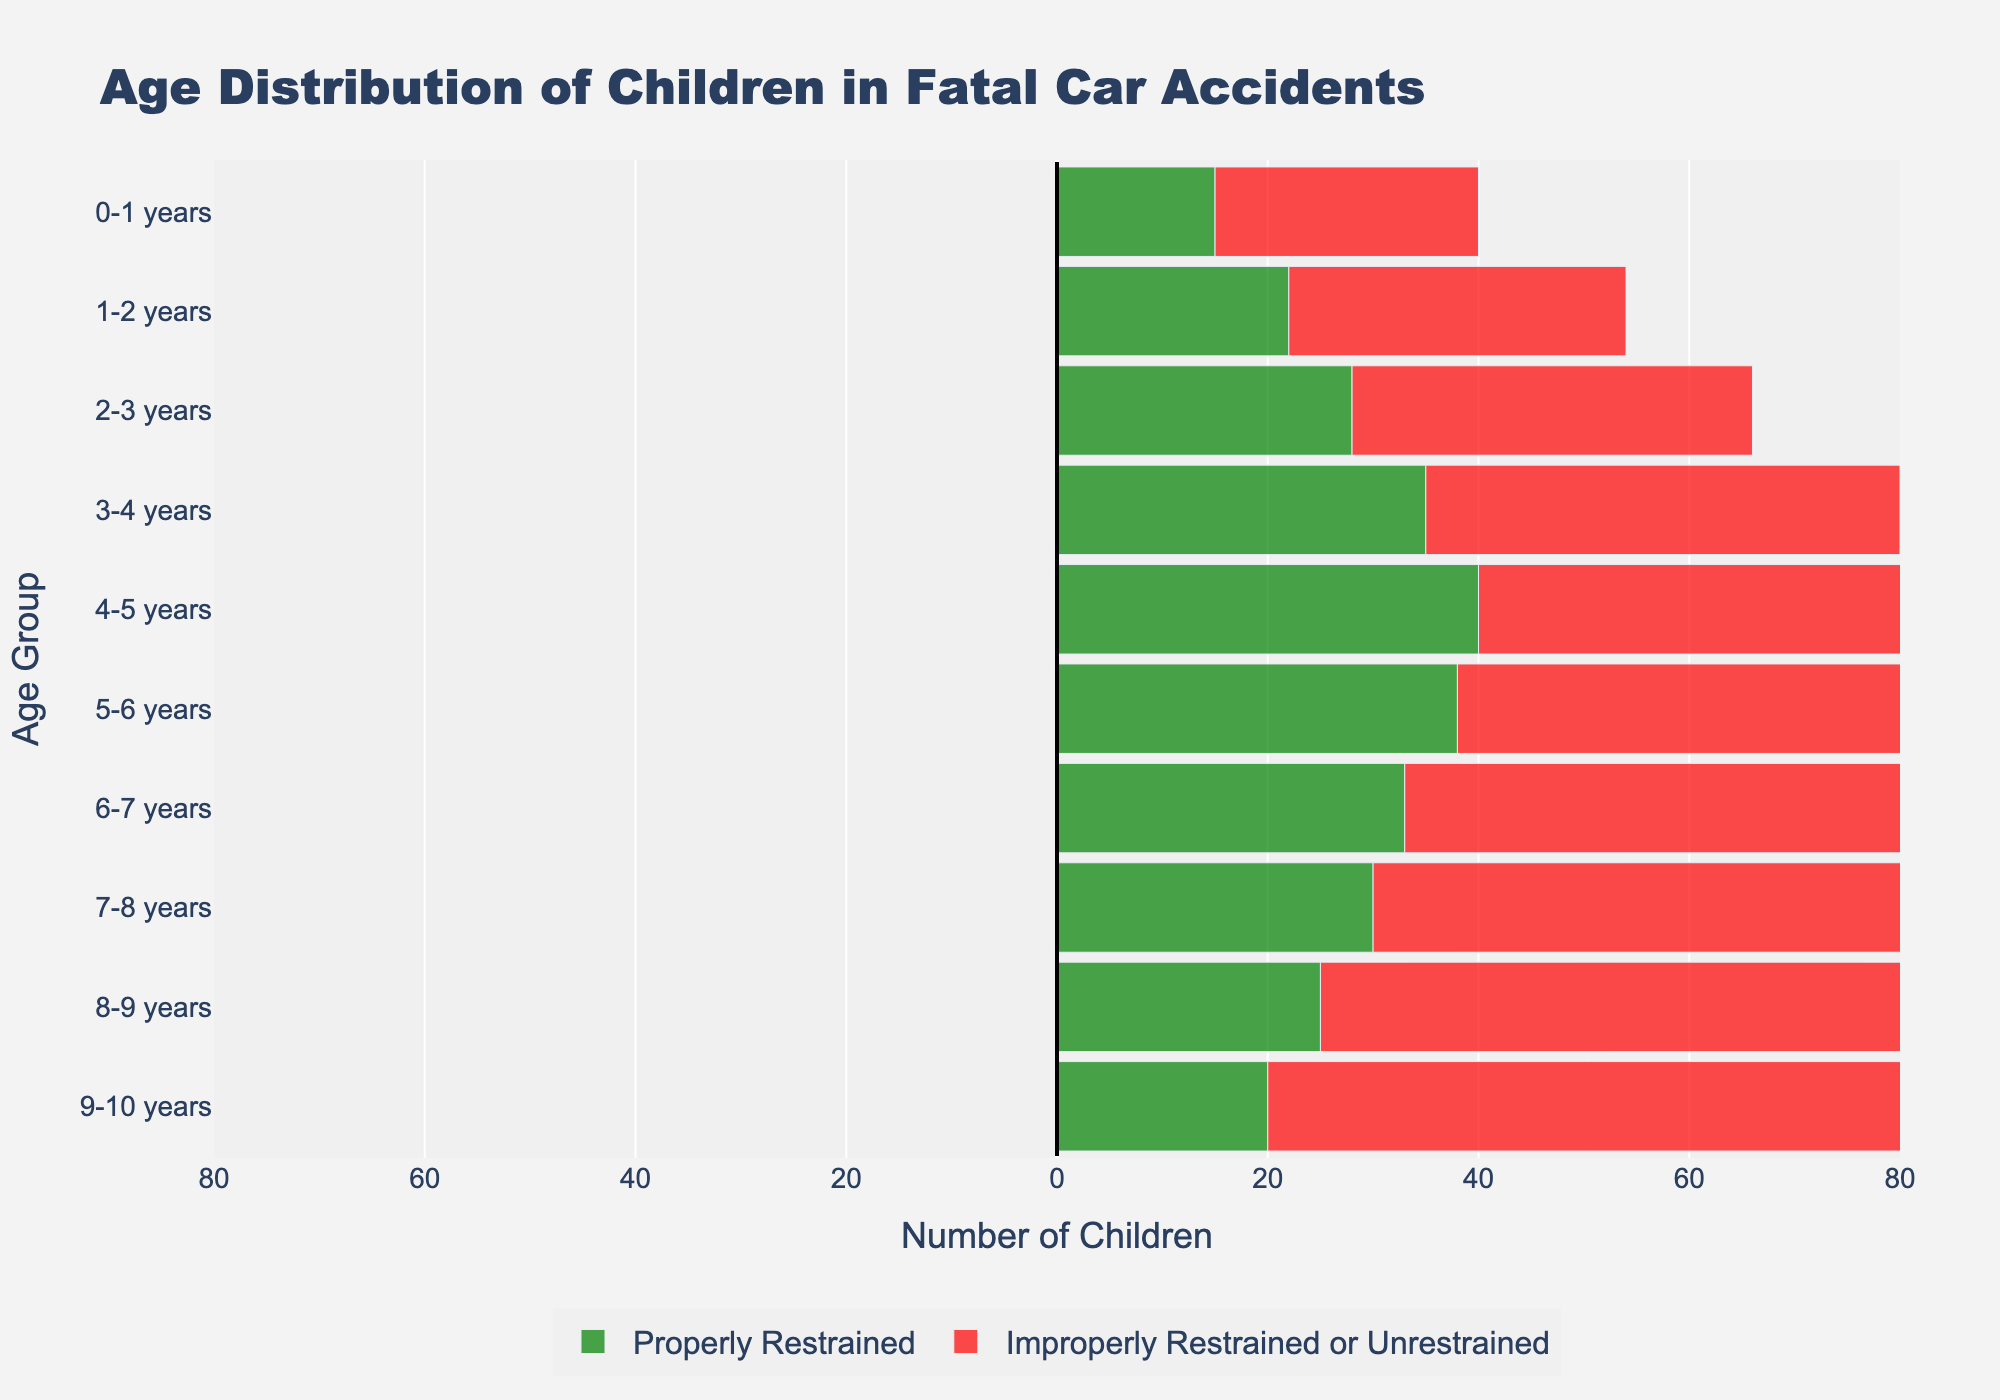What is the title of the figure? The title of the figure is placed prominently at the top. By reading the title text, we can understand that it is about the age distribution of children in fatal car accidents.
Answer: Age Distribution of Children in Fatal Car Accidents What is the age group with the highest number of improperly restrained or unrestrained children in fatal car accidents? By observing the red bars on the right side of the population pyramid, we can identify that the age group with the longest bar represents the highest number. The 9-10 years age group has the longest red bar.
Answer: 9-10 years How many children aged 3-4 years were properly restrained in fatal car accidents? By looking at the green bar corresponding to the 3-4 years age group on the left side of the pyramid, we see the negative value represents properly restrained children. The length of the green bar corresponds to -35 children.
Answer: 35 What is the total number of improperly restrained or unrestrained children across all age groups? To find this, we need to sum all the values of the red bars: 25 + 32 + 38 + 45 + 52 + 58 + 63 + 68 + 72 + 75 = 528.
Answer: 528 Which age group has the smallest difference between properly restrained and improperly restrained or unrestrained children? To determine this, calculate the absolute differences for each age group and find the minimum: [25 - 15 = 10, 32 - 22 = 10, 38 - 28 = 10, 45 - 35 = 10, 52 - 40 = 12, 58 - 38 = 20, 63 - 33 = 30, 68 - 30 = 38, 72 - 25 = 47, 75 - 20 = 55]. The smallest difference is 10 for the age groups 0-1, 1-2, 2-3, and 3-4.
Answer: 0-1, 1-2, 2-3, 3-4 How does the number of properly restrained children in the 6-7 years age group compare to those improperly restrained or unrestrained in the same age group? Compare the absolute values of the green bar (properly restrained) and the red bar (improperly restrained/unrestrained) for the 6-7 years age group: 33 (properly) versus 63 (improperly/unrestrained).
Answer: Lower What is the average number of properly restrained children across all age groups? Calculate the sum of all values in the green bars and then divide by the number of age groups: (15 + 22 + 28 + 35 + 40 + 38 + 33 + 30 + 25 + 20) / 10 = 28.6.
Answer: 28.6 Which age group shows the most significant imbalance between properly restrained and improperly restrained or unrestrained children? Find the age group with the largest difference between the red and green bars. The calculations show the largest difference is for the 9-10 years age group: 75 - 20 = 55.
Answer: 9-10 years What is the cumulative number of fatalities (both properly and improperly restrained) for children aged 5-6 years? Sum the values of both bars for the 5-6 years age group: 38 (properly restrained) + 58 (improperly restrained/unrestrained) = 96.
Answer: 96 How does the overall trend in the number of improperly restrained or unrestrained children change as age increases? Observe the pattern of the red bars from top to bottom. The bars generally increase in length, indicating more improperly restrained or unrestrained children as age increases.
Answer: Increasing 